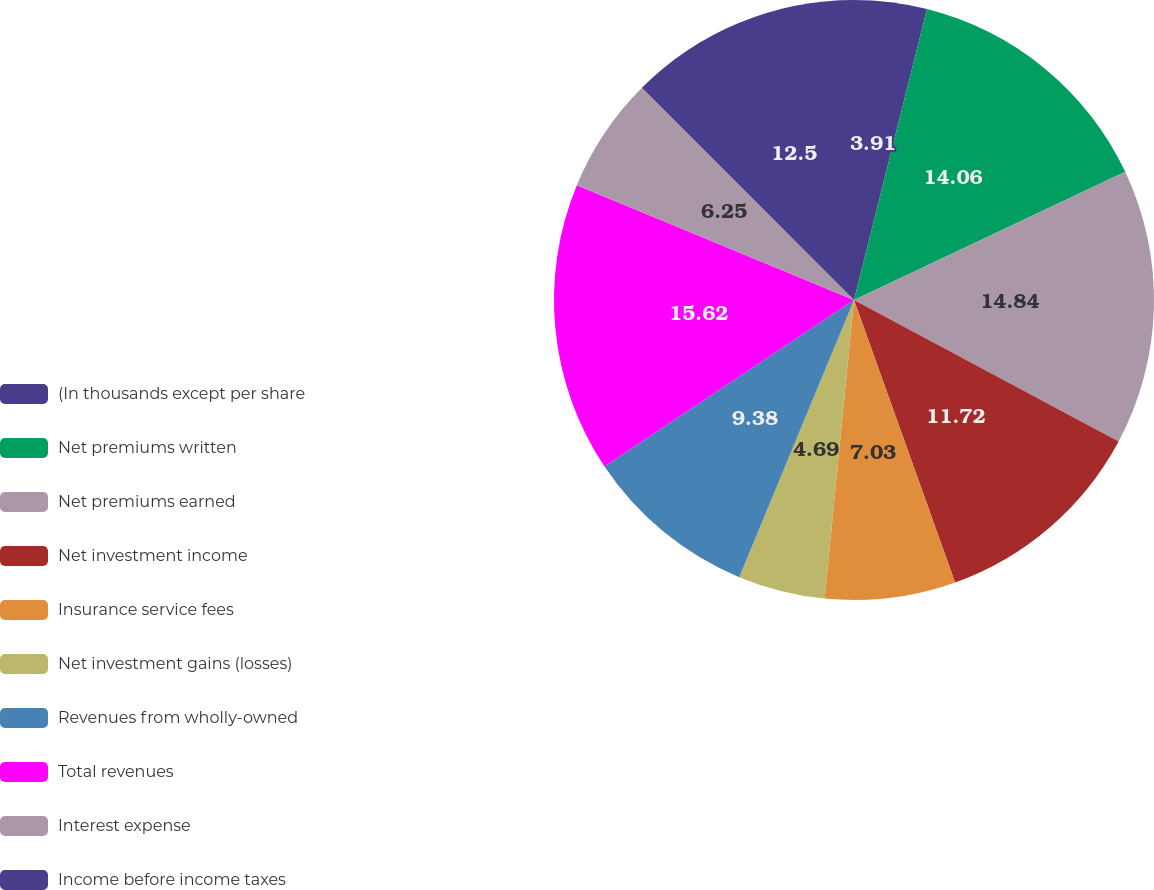<chart> <loc_0><loc_0><loc_500><loc_500><pie_chart><fcel>(In thousands except per share<fcel>Net premiums written<fcel>Net premiums earned<fcel>Net investment income<fcel>Insurance service fees<fcel>Net investment gains (losses)<fcel>Revenues from wholly-owned<fcel>Total revenues<fcel>Interest expense<fcel>Income before income taxes<nl><fcel>3.91%<fcel>14.06%<fcel>14.84%<fcel>11.72%<fcel>7.03%<fcel>4.69%<fcel>9.38%<fcel>15.62%<fcel>6.25%<fcel>12.5%<nl></chart> 